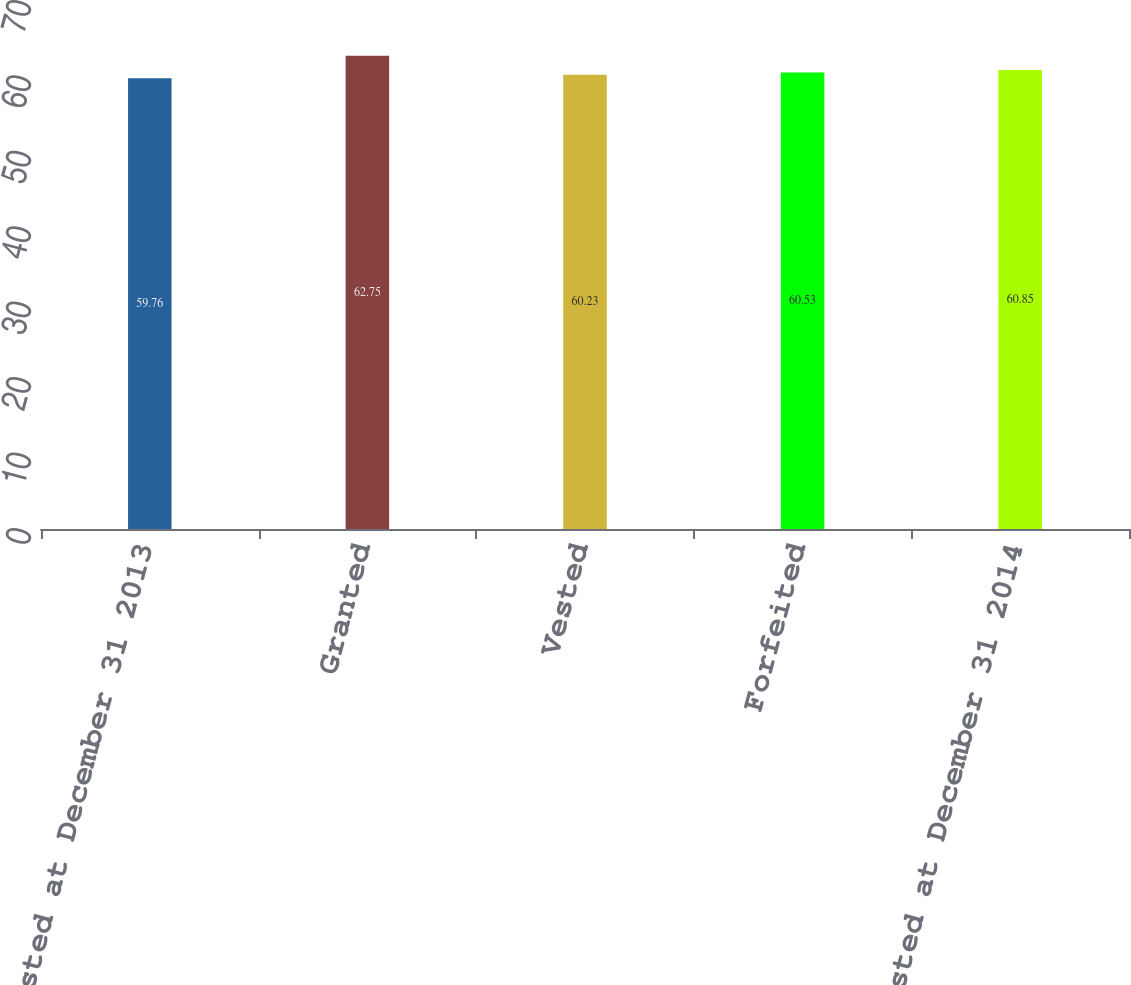Convert chart to OTSL. <chart><loc_0><loc_0><loc_500><loc_500><bar_chart><fcel>Unvested at December 31 2013<fcel>Granted<fcel>Vested<fcel>Forfeited<fcel>Unvested at December 31 2014<nl><fcel>59.76<fcel>62.75<fcel>60.23<fcel>60.53<fcel>60.85<nl></chart> 